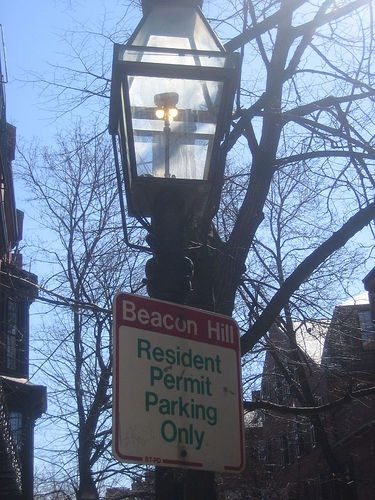Describe the objects in this image and their specific colors. I can see various objects in this image with different colors. 